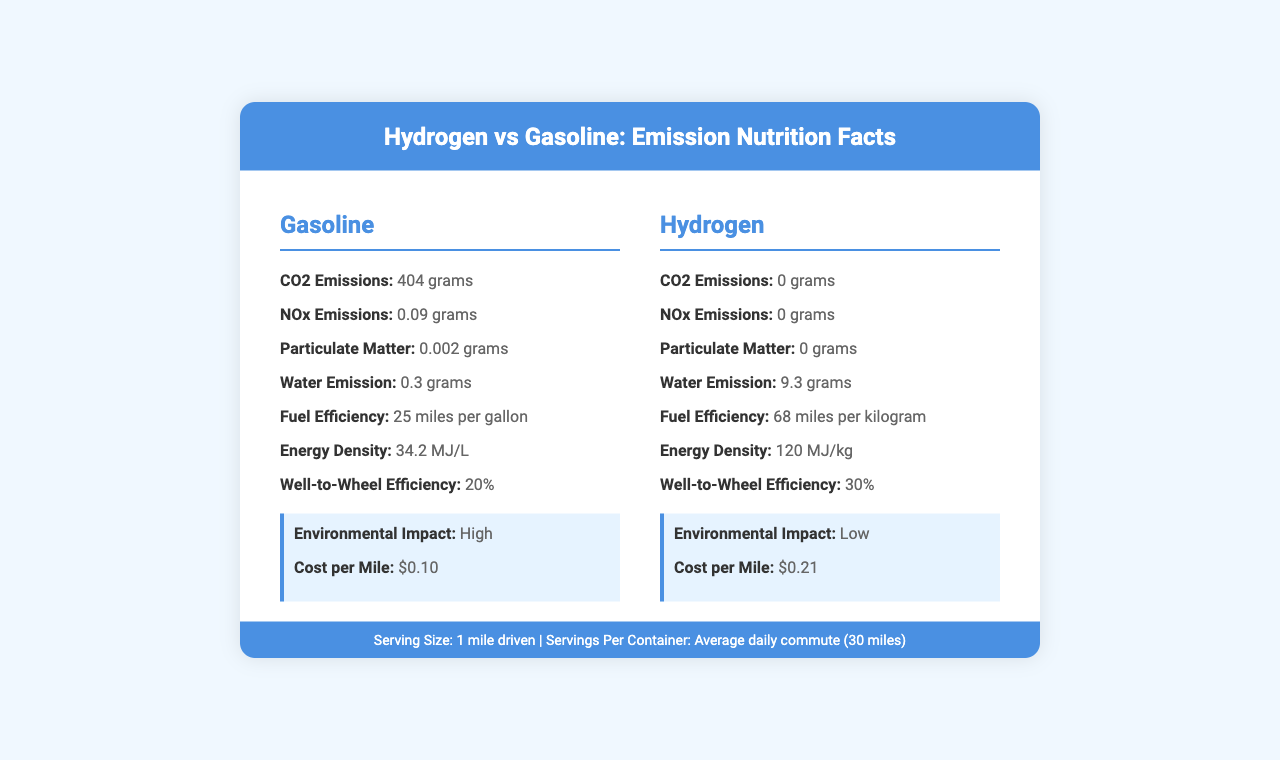what is the CO2 emission for gasoline per mile driven? The document states that the CO2 emission for gasoline per mile driven is 404 grams.
Answer: 404 grams how many nitrogen oxides are emitted per mile driven by hydrogen vehicles? According to the document, hydrogen vehicles emit 0 grams of nitrogen oxides per mile driven.
Answer: 0 grams what is the fuel efficiency of hydrogen vehicles? The document specifies that hydrogen vehicles have a fuel efficiency of 68 miles per kilogram.
Answer: 68 miles per kilogram what is the source of production for hydrogen? The document lists steam methane reforming and electrolysis as the sources of production for hydrogen.
Answer: Steam methane reforming, Electrolysis name three gasoline vehicles mentioned in the document. The gasoline vehicles mentioned in the document are Toyota Camry, Honda Civic, and Ford F-150.
Answer: Toyota Camry, Honda Civic, Ford F-150 how much water is emitted by hydrogen vehicles per mile driven? A. 0 grams B. 0.3 grams C. 9.3 grams D. 4.5 grams The document states that hydrogen vehicles emit 9.3 grams of water per mile driven.
Answer: C. 9.3 grams which has a higher well-to-wheel efficiency? I. Gasoline II. Hydrogen III. Both are equal The well-to-wheel efficiency for gasoline is 20%, while it is 30% for hydrogen, making hydrogen the more efficient option.
Answer: II. Hydrogen do gasoline vehicles emit particulate matter? The document indicates that gasoline vehicles emit 0.002 grams of particulate matter per mile driven.
Answer: Yes describe the main idea of the document. The main idea is to provide a detailed comparison between gasoline and hydrogen vehicles across various parameters, highlighting the environmental benefits of hydrogen despite its higher cost and limited infrastructure.
Answer: The document compares the emissions, fuel efficiency, energy density, production sources, environmental impact, and cost per mile of gasoline and hydrogen vehicles. It concludes that hydrogen vehicles have lower emissions and environmental impact but are currently more expensive and less widely supported by infrastructure. what is the cost per mile for hydrogen vehicles? The document states that the cost per mile for hydrogen vehicles is $0.21.
Answer: $0.21 which source of production has lower environmental impact according to the document? The document lists the environmental impact of hydrogen as "Low" compared to gasoline's "High".
Answer: Hydrogen how many hydrogen refueling stations are there in the US? The document mentions that there are 48 hydrogen refueling stations in the US.
Answer: 48 stations what is the energy density of gasoline? According to the document, the energy density of gasoline is 34.2 MJ/L.
Answer: 34.2 MJ/L can we determine the exact number of miles driven annually by the average driver from this document? The document provides information on the emissions and efficiency per mile and per average daily commute, but it does not provide the exact number of miles driven annually by the average driver.
Answer: No, Not enough information 